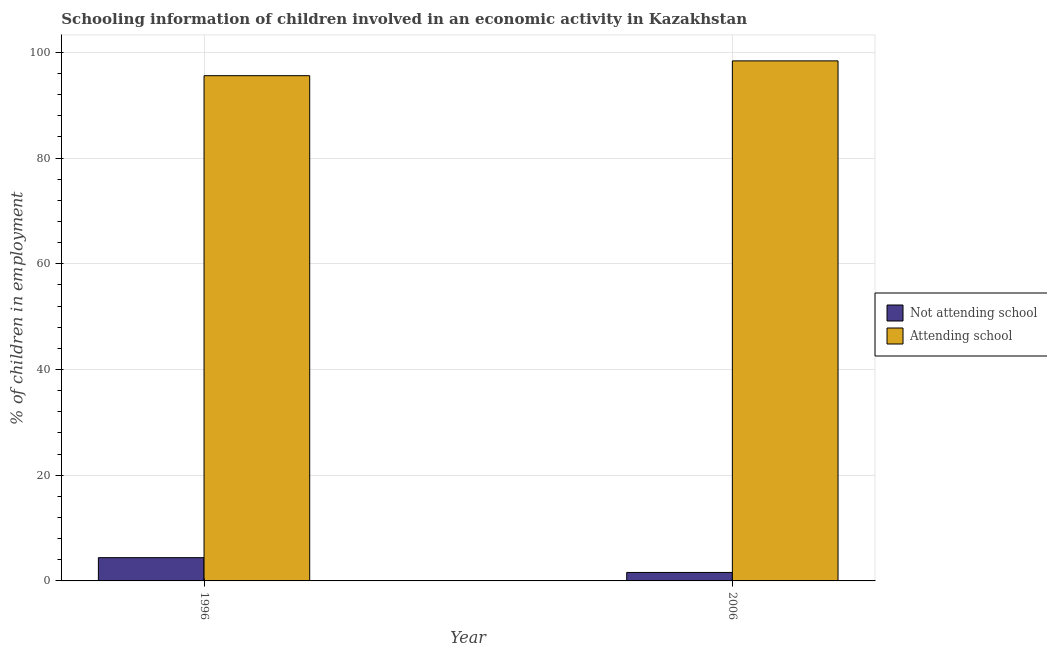How many groups of bars are there?
Ensure brevity in your answer.  2. Are the number of bars per tick equal to the number of legend labels?
Offer a very short reply. Yes. Are the number of bars on each tick of the X-axis equal?
Give a very brief answer. Yes. How many bars are there on the 1st tick from the right?
Offer a terse response. 2. What is the label of the 2nd group of bars from the left?
Your answer should be compact. 2006. In how many cases, is the number of bars for a given year not equal to the number of legend labels?
Your response must be concise. 0. What is the percentage of employed children who are attending school in 1996?
Give a very brief answer. 95.6. Across all years, what is the maximum percentage of employed children who are attending school?
Your response must be concise. 98.4. Across all years, what is the minimum percentage of employed children who are not attending school?
Provide a succinct answer. 1.6. In which year was the percentage of employed children who are not attending school minimum?
Your answer should be very brief. 2006. What is the difference between the percentage of employed children who are attending school in 1996 and that in 2006?
Your answer should be compact. -2.8. What is the difference between the percentage of employed children who are attending school in 2006 and the percentage of employed children who are not attending school in 1996?
Ensure brevity in your answer.  2.8. What is the average percentage of employed children who are attending school per year?
Offer a very short reply. 97. In the year 2006, what is the difference between the percentage of employed children who are not attending school and percentage of employed children who are attending school?
Offer a very short reply. 0. In how many years, is the percentage of employed children who are attending school greater than 32 %?
Your answer should be compact. 2. What is the ratio of the percentage of employed children who are not attending school in 1996 to that in 2006?
Your answer should be compact. 2.75. In how many years, is the percentage of employed children who are not attending school greater than the average percentage of employed children who are not attending school taken over all years?
Make the answer very short. 1. What does the 2nd bar from the left in 1996 represents?
Your response must be concise. Attending school. What does the 2nd bar from the right in 1996 represents?
Make the answer very short. Not attending school. Are all the bars in the graph horizontal?
Give a very brief answer. No. How many years are there in the graph?
Keep it short and to the point. 2. What is the difference between two consecutive major ticks on the Y-axis?
Provide a short and direct response. 20. Are the values on the major ticks of Y-axis written in scientific E-notation?
Your response must be concise. No. Does the graph contain grids?
Your answer should be compact. Yes. Where does the legend appear in the graph?
Provide a succinct answer. Center right. How many legend labels are there?
Offer a very short reply. 2. How are the legend labels stacked?
Give a very brief answer. Vertical. What is the title of the graph?
Make the answer very short. Schooling information of children involved in an economic activity in Kazakhstan. Does "Rural" appear as one of the legend labels in the graph?
Your response must be concise. No. What is the label or title of the Y-axis?
Offer a terse response. % of children in employment. What is the % of children in employment in Not attending school in 1996?
Your response must be concise. 4.4. What is the % of children in employment in Attending school in 1996?
Give a very brief answer. 95.6. What is the % of children in employment of Attending school in 2006?
Your response must be concise. 98.4. Across all years, what is the maximum % of children in employment in Not attending school?
Ensure brevity in your answer.  4.4. Across all years, what is the maximum % of children in employment in Attending school?
Offer a very short reply. 98.4. Across all years, what is the minimum % of children in employment in Attending school?
Make the answer very short. 95.6. What is the total % of children in employment of Attending school in the graph?
Keep it short and to the point. 194. What is the difference between the % of children in employment in Not attending school in 1996 and that in 2006?
Provide a succinct answer. 2.8. What is the difference between the % of children in employment of Attending school in 1996 and that in 2006?
Offer a very short reply. -2.8. What is the difference between the % of children in employment of Not attending school in 1996 and the % of children in employment of Attending school in 2006?
Provide a short and direct response. -94. What is the average % of children in employment in Attending school per year?
Your response must be concise. 97. In the year 1996, what is the difference between the % of children in employment of Not attending school and % of children in employment of Attending school?
Make the answer very short. -91.2. In the year 2006, what is the difference between the % of children in employment in Not attending school and % of children in employment in Attending school?
Offer a very short reply. -96.8. What is the ratio of the % of children in employment of Not attending school in 1996 to that in 2006?
Provide a short and direct response. 2.75. What is the ratio of the % of children in employment of Attending school in 1996 to that in 2006?
Give a very brief answer. 0.97. What is the difference between the highest and the second highest % of children in employment in Not attending school?
Offer a very short reply. 2.8. What is the difference between the highest and the lowest % of children in employment in Not attending school?
Make the answer very short. 2.8. 